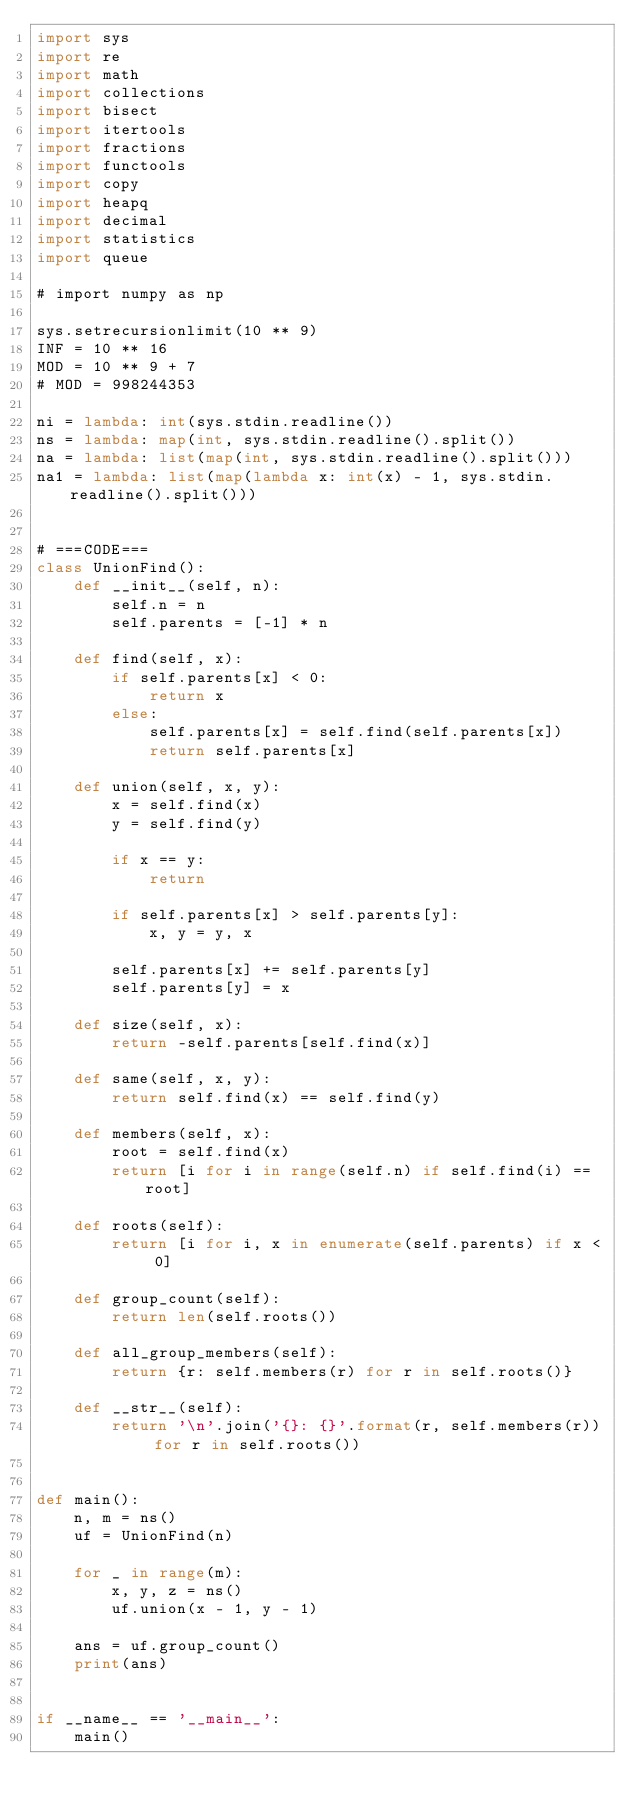Convert code to text. <code><loc_0><loc_0><loc_500><loc_500><_Python_>import sys
import re
import math
import collections
import bisect
import itertools
import fractions
import functools
import copy
import heapq
import decimal
import statistics
import queue

# import numpy as np

sys.setrecursionlimit(10 ** 9)
INF = 10 ** 16
MOD = 10 ** 9 + 7
# MOD = 998244353

ni = lambda: int(sys.stdin.readline())
ns = lambda: map(int, sys.stdin.readline().split())
na = lambda: list(map(int, sys.stdin.readline().split()))
na1 = lambda: list(map(lambda x: int(x) - 1, sys.stdin.readline().split()))


# ===CODE===
class UnionFind():
    def __init__(self, n):
        self.n = n
        self.parents = [-1] * n

    def find(self, x):
        if self.parents[x] < 0:
            return x
        else:
            self.parents[x] = self.find(self.parents[x])
            return self.parents[x]

    def union(self, x, y):
        x = self.find(x)
        y = self.find(y)

        if x == y:
            return

        if self.parents[x] > self.parents[y]:
            x, y = y, x

        self.parents[x] += self.parents[y]
        self.parents[y] = x

    def size(self, x):
        return -self.parents[self.find(x)]

    def same(self, x, y):
        return self.find(x) == self.find(y)

    def members(self, x):
        root = self.find(x)
        return [i for i in range(self.n) if self.find(i) == root]

    def roots(self):
        return [i for i, x in enumerate(self.parents) if x < 0]

    def group_count(self):
        return len(self.roots())

    def all_group_members(self):
        return {r: self.members(r) for r in self.roots()}

    def __str__(self):
        return '\n'.join('{}: {}'.format(r, self.members(r)) for r in self.roots())


def main():
    n, m = ns()
    uf = UnionFind(n)

    for _ in range(m):
        x, y, z = ns()
        uf.union(x - 1, y - 1)

    ans = uf.group_count()
    print(ans)


if __name__ == '__main__':
    main()
</code> 